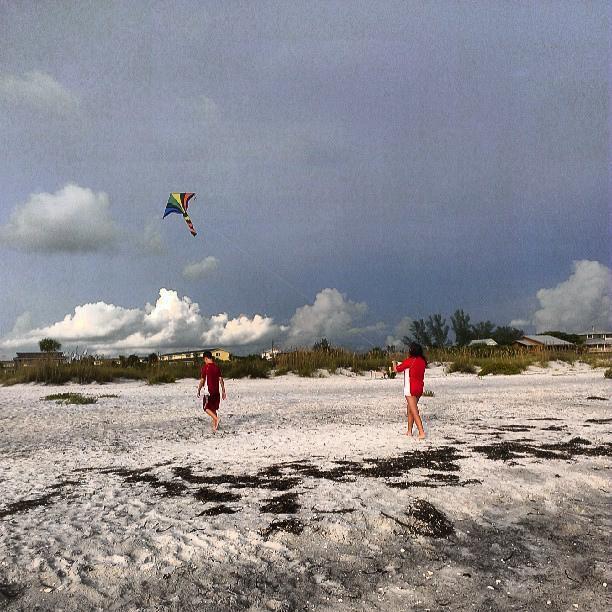How many different kinds of apples are there?
Give a very brief answer. 0. 